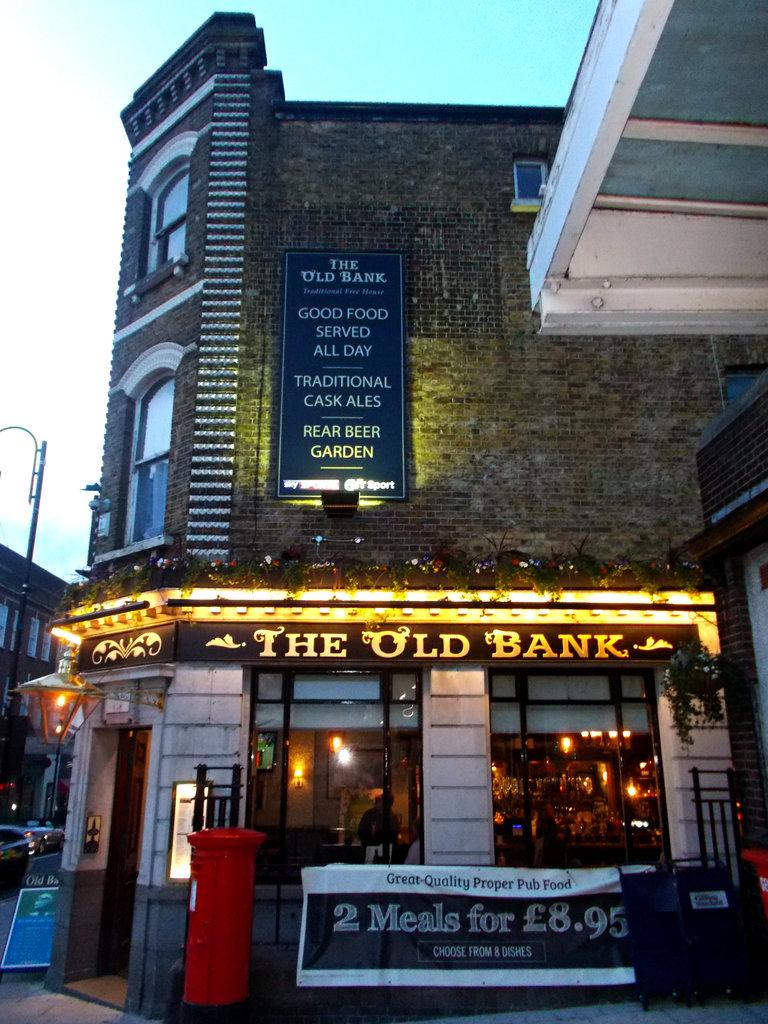What type of structure is present in the image? There is a building in the image. What is located within the building? The building has a shop in the front. What is the name of the shop? The sign on the shop says "The Old Bank." What can be seen at the top of the image? The sky is visible at the top of the image. What type of thread is used to sew the curtains in the shop? There is no information about curtains or thread in the image, so we cannot determine the type of thread used. 